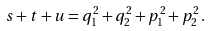Convert formula to latex. <formula><loc_0><loc_0><loc_500><loc_500>s + t + u = q _ { 1 } ^ { 2 } + q _ { 2 } ^ { 2 } + p _ { 1 } ^ { 2 } + p _ { 2 } ^ { 2 } \, .</formula> 